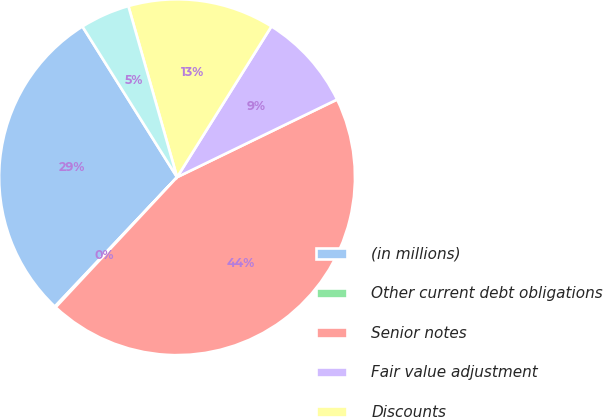Convert chart. <chart><loc_0><loc_0><loc_500><loc_500><pie_chart><fcel>(in millions)<fcel>Other current debt obligations<fcel>Senior notes<fcel>Fair value adjustment<fcel>Discounts<fcel>Other<nl><fcel>29.03%<fcel>0.1%<fcel>44.14%<fcel>8.91%<fcel>13.31%<fcel>4.51%<nl></chart> 